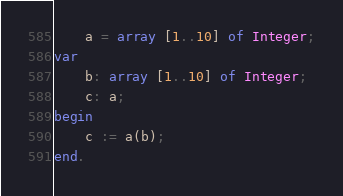<code> <loc_0><loc_0><loc_500><loc_500><_Pascal_>    a = array [1..10] of Integer;
var
    b: array [1..10] of Integer;
    c: a;
begin
    c := a(b);
end.</code> 